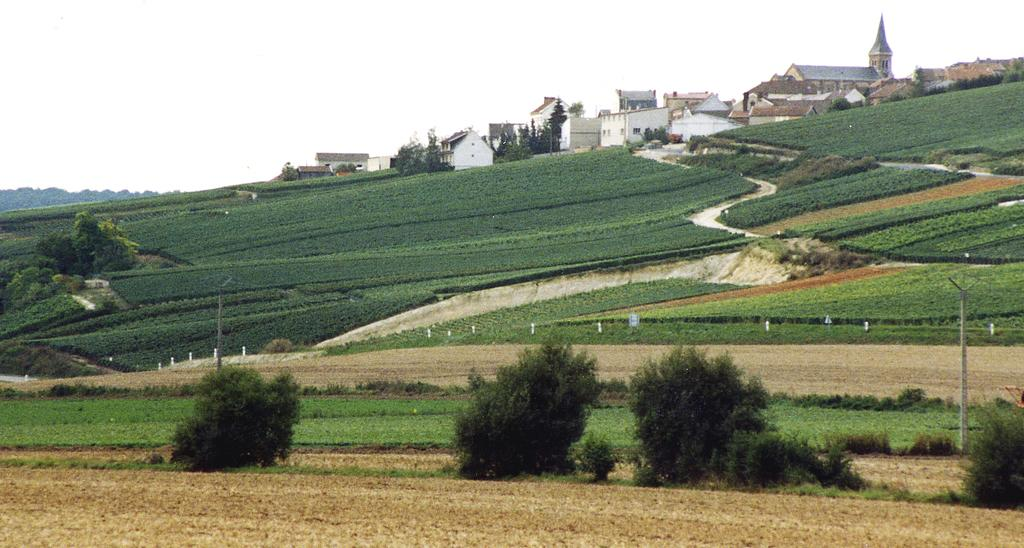What type of vegetation can be seen in the image? There are plants and trees in the image. What type of structures are present in the image? There are buildings in the image. What other objects can be seen in the image? There are electrical poles in the image. What natural landmarks are visible in the image? There are mountains in the image. What type of ground surface is visible at the bottom of the image? There is grass on the surface at the bottom of the image. What part of the natural environment is visible at the top of the image? There is sky visible at the top of the image. What type of eggnog is being served in the image? There is no eggnog present in the image. What type of system is being used to generate electricity in the image? There is no specific system visible in the image; only electrical poles are present. 